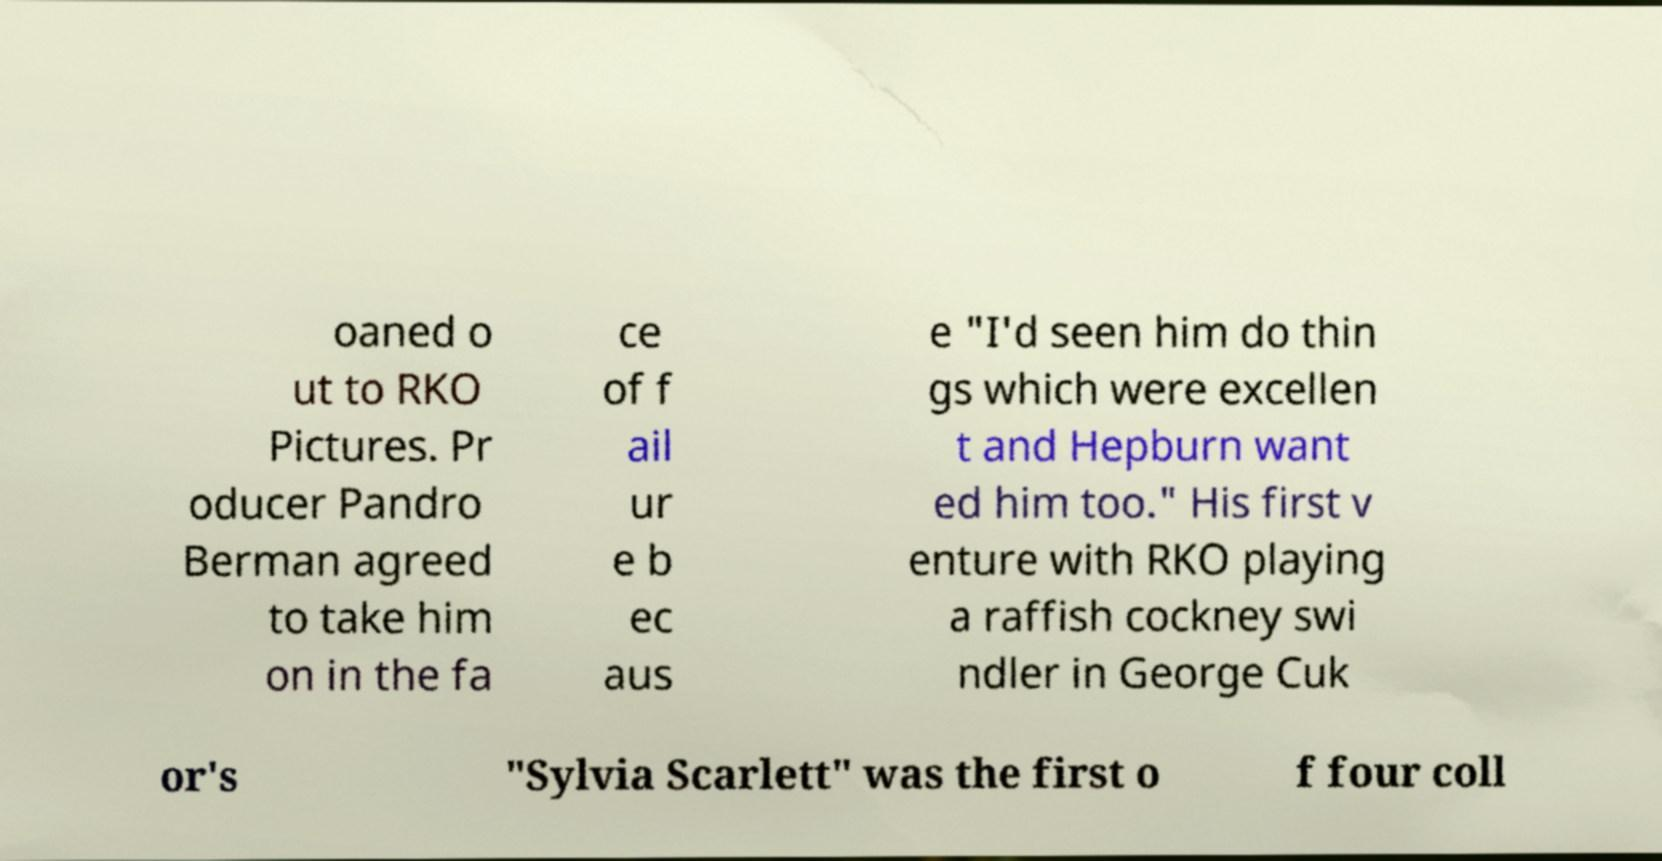Can you read and provide the text displayed in the image?This photo seems to have some interesting text. Can you extract and type it out for me? oaned o ut to RKO Pictures. Pr oducer Pandro Berman agreed to take him on in the fa ce of f ail ur e b ec aus e "I'd seen him do thin gs which were excellen t and Hepburn want ed him too." His first v enture with RKO playing a raffish cockney swi ndler in George Cuk or's "Sylvia Scarlett" was the first o f four coll 